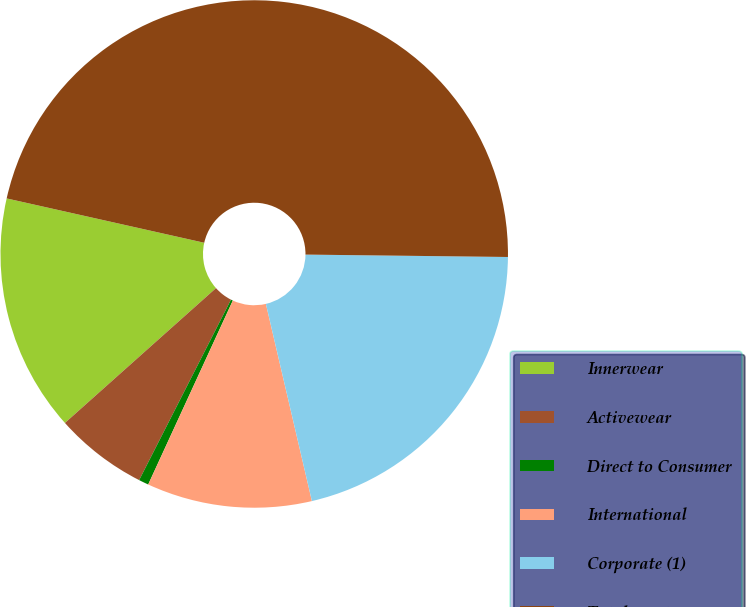Convert chart to OTSL. <chart><loc_0><loc_0><loc_500><loc_500><pie_chart><fcel>Innerwear<fcel>Activewear<fcel>Direct to Consumer<fcel>International<fcel>Corporate (1)<fcel>Total assets<nl><fcel>15.11%<fcel>5.91%<fcel>0.63%<fcel>10.51%<fcel>21.16%<fcel>46.67%<nl></chart> 